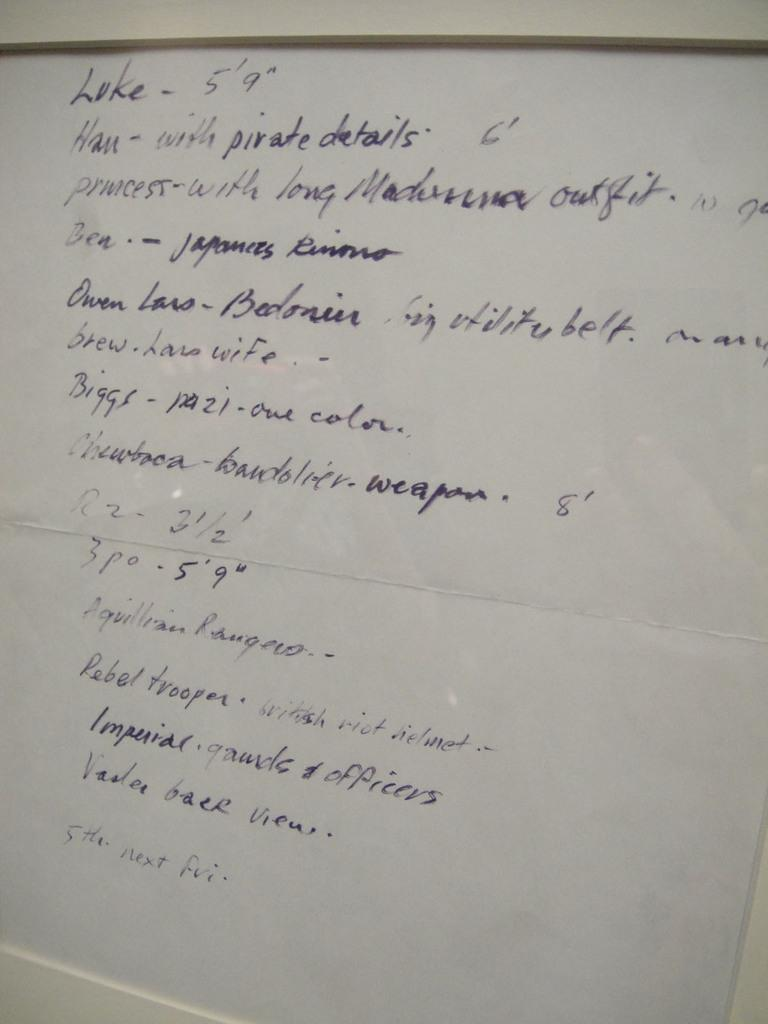Provide a one-sentence caption for the provided image. A handwritten page of writing which starts with the word Luke. 